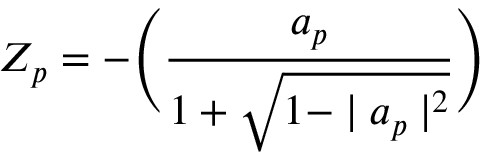<formula> <loc_0><loc_0><loc_500><loc_500>Z _ { p } = - \left ( \frac { a _ { p } } { 1 + \sqrt { 1 - | a _ { p } | ^ { 2 } } } \right )</formula> 